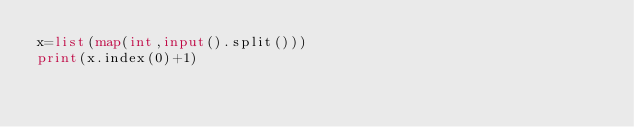Convert code to text. <code><loc_0><loc_0><loc_500><loc_500><_Python_>x=list(map(int,input().split()))
print(x.index(0)+1)</code> 